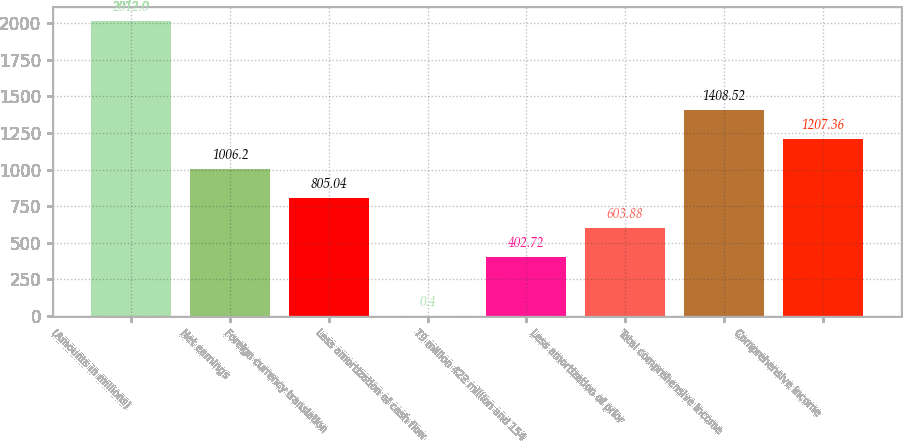Convert chart. <chart><loc_0><loc_0><loc_500><loc_500><bar_chart><fcel>(Amounts in millions)<fcel>Net earnings<fcel>Foreign currency translation<fcel>Less amortization of cash flow<fcel>79 million 422 million and 154<fcel>Less amortization of prior<fcel>Total comprehensive income<fcel>Comprehensive income<nl><fcel>2012<fcel>1006.2<fcel>805.04<fcel>0.4<fcel>402.72<fcel>603.88<fcel>1408.52<fcel>1207.36<nl></chart> 